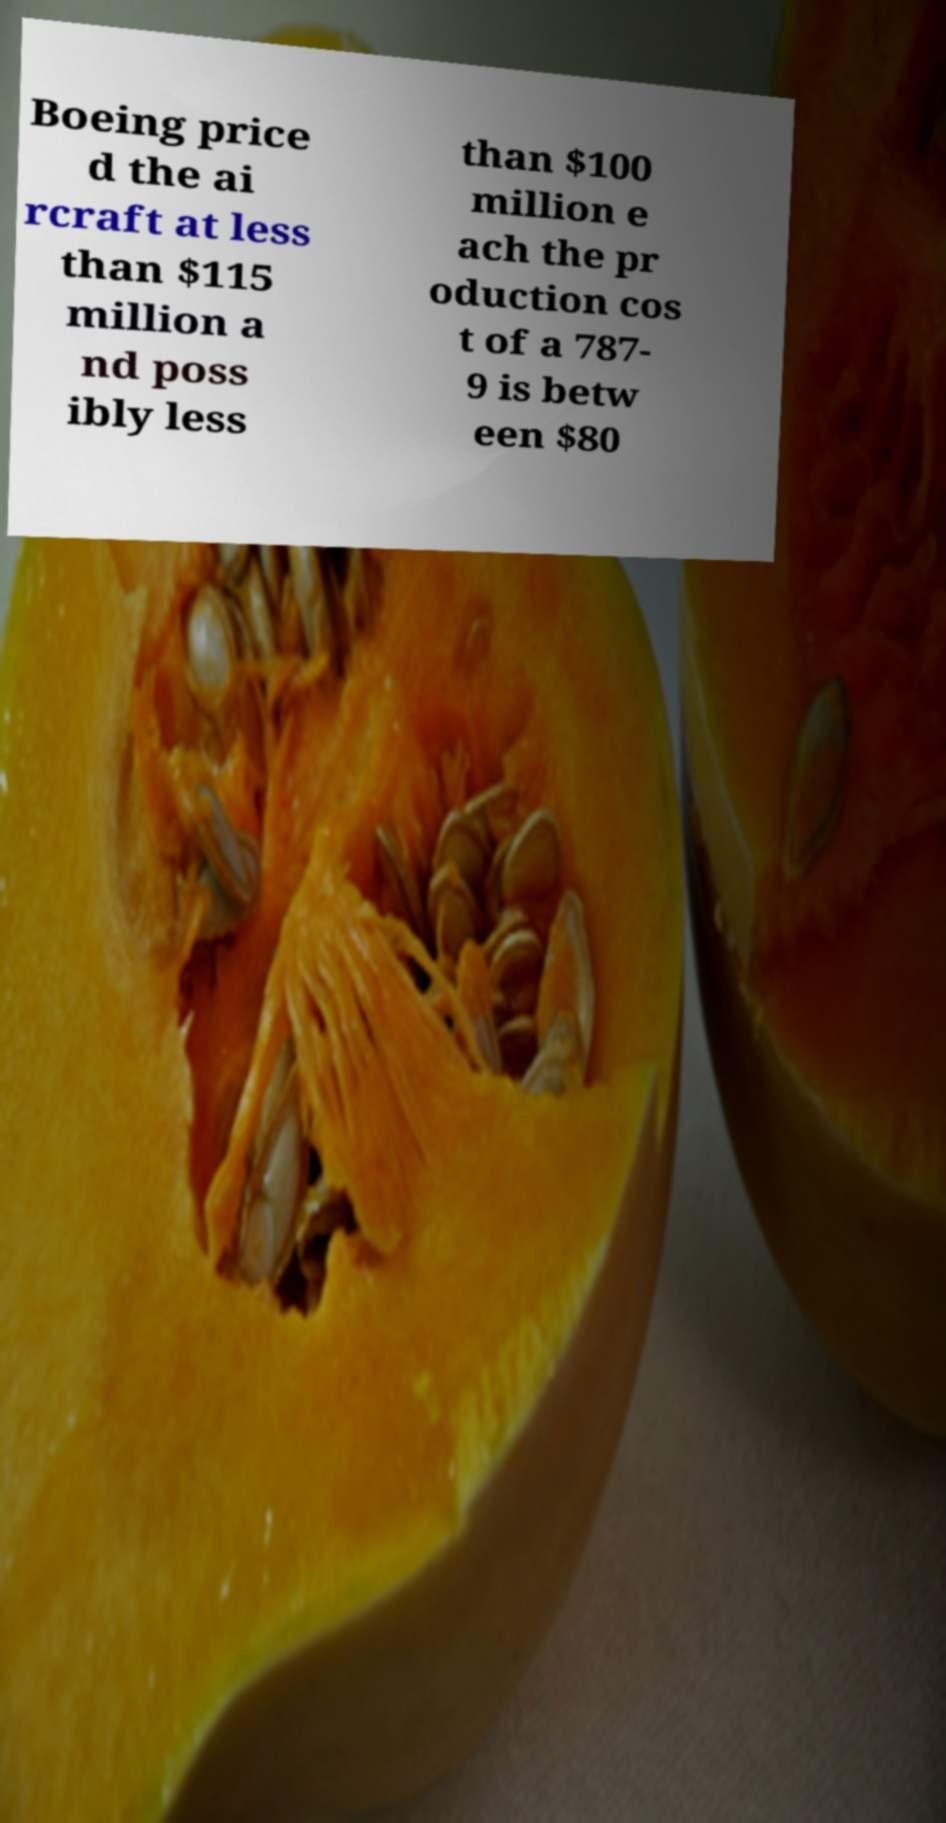What messages or text are displayed in this image? I need them in a readable, typed format. Boeing price d the ai rcraft at less than $115 million a nd poss ibly less than $100 million e ach the pr oduction cos t of a 787- 9 is betw een $80 